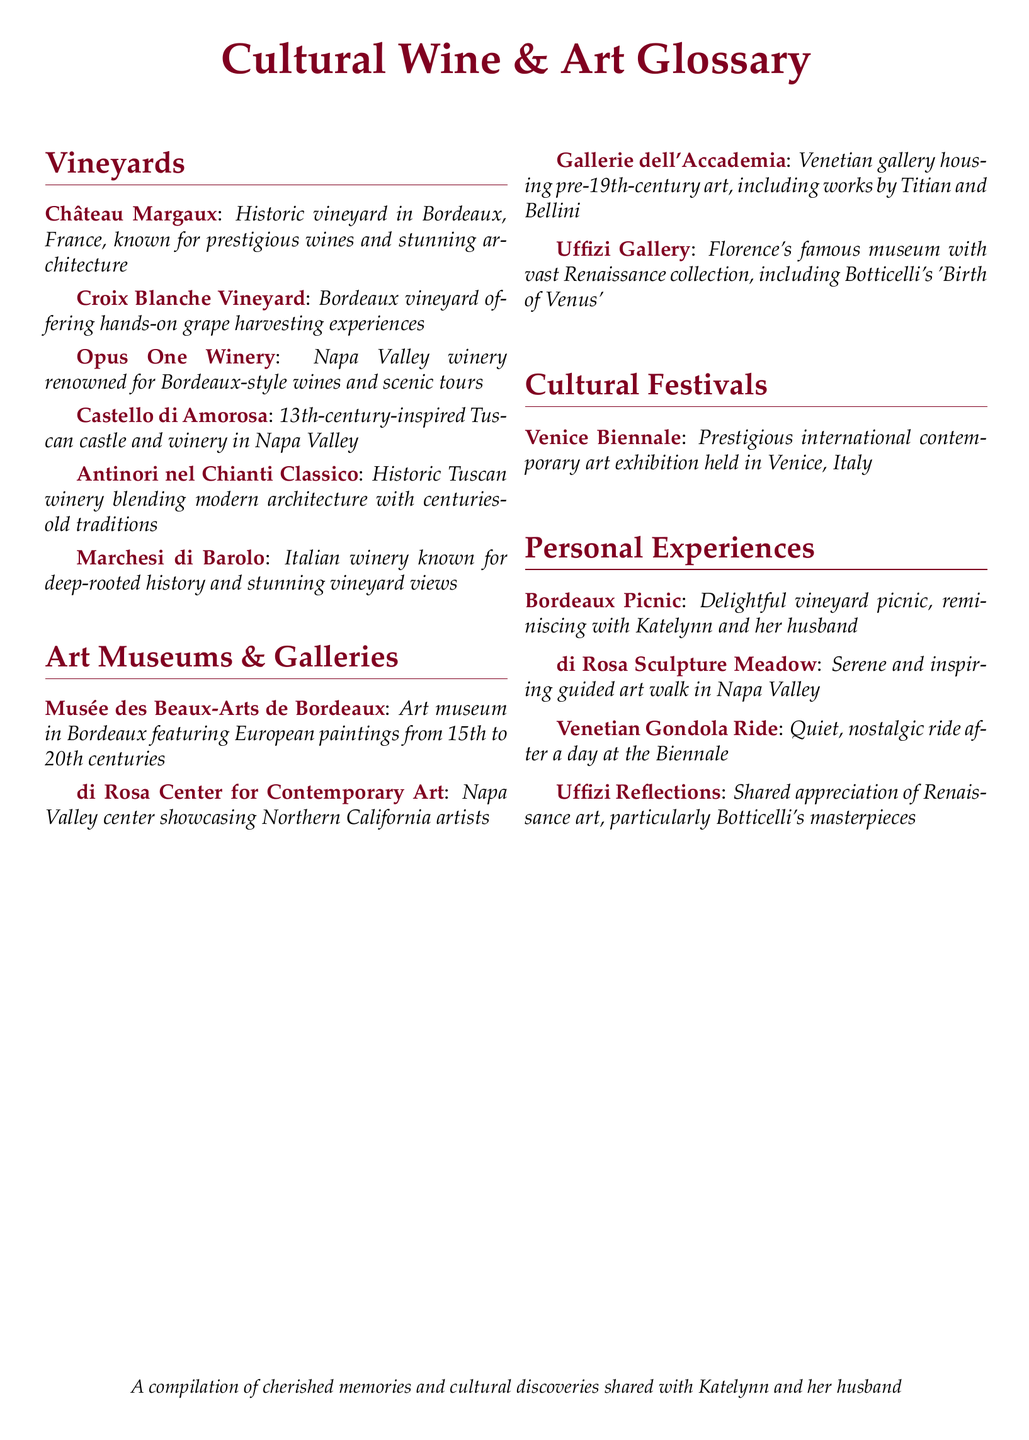What is Château Margaux? Château Margaux is a historic vineyard in Bordeaux, France, known for prestigious wines and stunning architecture.
Answer: Historic vineyard in Bordeaux What is the main focus of the Cultural Trip Summaries? The main focus is on cultural experiences, including visits to vineyards, art museums, galleries, and cultural festivals.
Answer: Cultural experiences Where is the di Rosa Center for Contemporary Art located? The di Rosa Center is located in Napa Valley and showcases Northern California artists.
Answer: Napa Valley What type of art does the Uffizi Gallery primarily display? The Uffizi Gallery displays a vast collection of Renaissance art, including works by Botticelli.
Answer: Renaissance art What personal experience is associated with the Venice Biennale? The personal experience associated with the Venice Biennale is the Venetian Gondola Ride.
Answer: Venetian Gondola Ride Which vineyard offers hands-on grape harvesting experiences? The Croix Blanche Vineyard offers hands-on grape harvesting experiences.
Answer: Croix Blanche Vineyard How many sections are in the Cultural Wine & Art Glossary? There are four sections in the glossary: Vineyards, Art Museums & Galleries, Cultural Festivals, and Personal Experiences.
Answer: Four sections What is a memorable personal experience shared with Katelynn and her husband? A memorable experience is the Bordeaux Picnic.
Answer: Bordeaux Picnic What is the significance of Botticelli in the document? Botticelli is noted for his masterpieces appreciated in the Uffizi Reflections section.
Answer: Botticelli's masterpieces 